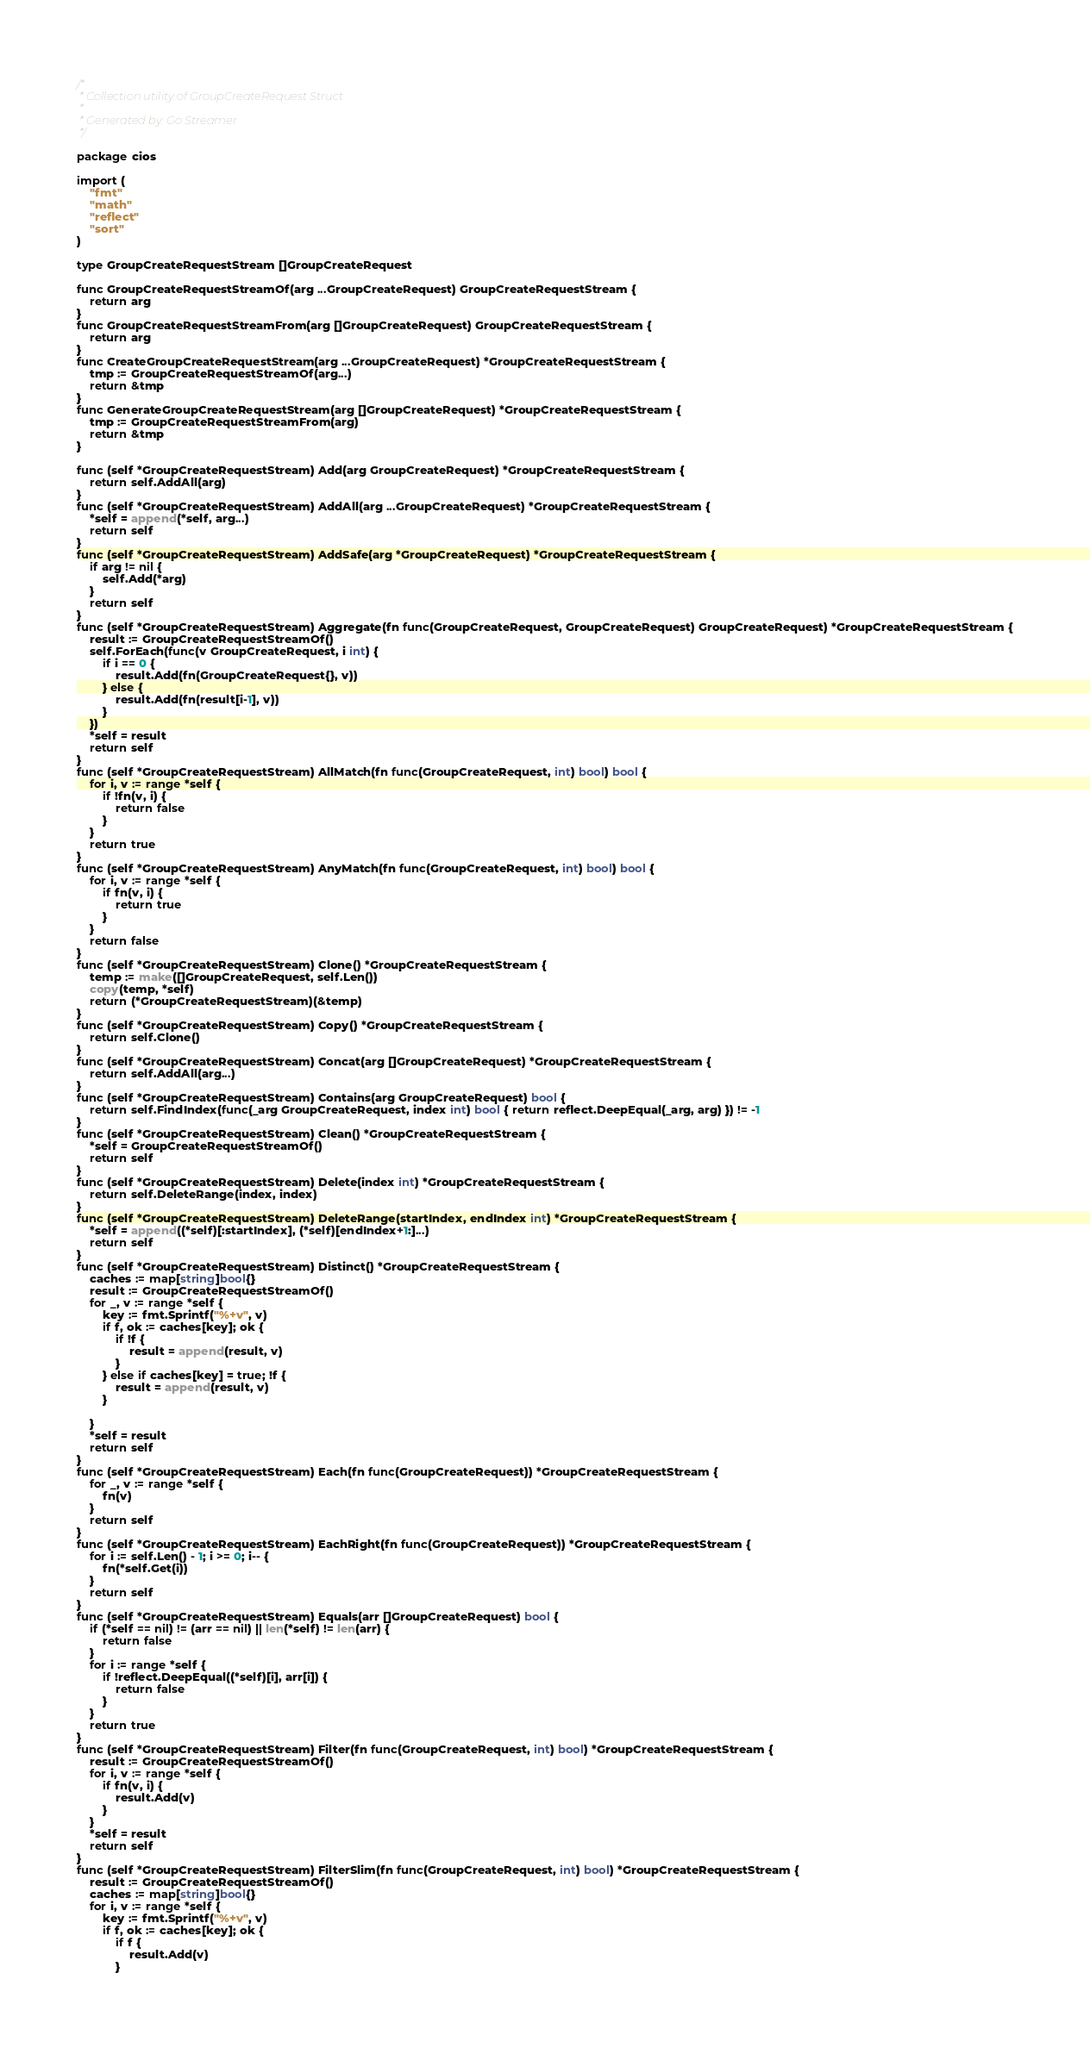Convert code to text. <code><loc_0><loc_0><loc_500><loc_500><_Go_>/*
 * Collection utility of GroupCreateRequest Struct
 *
 * Generated by: Go Streamer
 */

package cios

import (
	"fmt"
	"math"
	"reflect"
	"sort"
)

type GroupCreateRequestStream []GroupCreateRequest

func GroupCreateRequestStreamOf(arg ...GroupCreateRequest) GroupCreateRequestStream {
	return arg
}
func GroupCreateRequestStreamFrom(arg []GroupCreateRequest) GroupCreateRequestStream {
	return arg
}
func CreateGroupCreateRequestStream(arg ...GroupCreateRequest) *GroupCreateRequestStream {
	tmp := GroupCreateRequestStreamOf(arg...)
	return &tmp
}
func GenerateGroupCreateRequestStream(arg []GroupCreateRequest) *GroupCreateRequestStream {
	tmp := GroupCreateRequestStreamFrom(arg)
	return &tmp
}

func (self *GroupCreateRequestStream) Add(arg GroupCreateRequest) *GroupCreateRequestStream {
	return self.AddAll(arg)
}
func (self *GroupCreateRequestStream) AddAll(arg ...GroupCreateRequest) *GroupCreateRequestStream {
	*self = append(*self, arg...)
	return self
}
func (self *GroupCreateRequestStream) AddSafe(arg *GroupCreateRequest) *GroupCreateRequestStream {
	if arg != nil {
		self.Add(*arg)
	}
	return self
}
func (self *GroupCreateRequestStream) Aggregate(fn func(GroupCreateRequest, GroupCreateRequest) GroupCreateRequest) *GroupCreateRequestStream {
	result := GroupCreateRequestStreamOf()
	self.ForEach(func(v GroupCreateRequest, i int) {
		if i == 0 {
			result.Add(fn(GroupCreateRequest{}, v))
		} else {
			result.Add(fn(result[i-1], v))
		}
	})
	*self = result
	return self
}
func (self *GroupCreateRequestStream) AllMatch(fn func(GroupCreateRequest, int) bool) bool {
	for i, v := range *self {
		if !fn(v, i) {
			return false
		}
	}
	return true
}
func (self *GroupCreateRequestStream) AnyMatch(fn func(GroupCreateRequest, int) bool) bool {
	for i, v := range *self {
		if fn(v, i) {
			return true
		}
	}
	return false
}
func (self *GroupCreateRequestStream) Clone() *GroupCreateRequestStream {
	temp := make([]GroupCreateRequest, self.Len())
	copy(temp, *self)
	return (*GroupCreateRequestStream)(&temp)
}
func (self *GroupCreateRequestStream) Copy() *GroupCreateRequestStream {
	return self.Clone()
}
func (self *GroupCreateRequestStream) Concat(arg []GroupCreateRequest) *GroupCreateRequestStream {
	return self.AddAll(arg...)
}
func (self *GroupCreateRequestStream) Contains(arg GroupCreateRequest) bool {
	return self.FindIndex(func(_arg GroupCreateRequest, index int) bool { return reflect.DeepEqual(_arg, arg) }) != -1
}
func (self *GroupCreateRequestStream) Clean() *GroupCreateRequestStream {
	*self = GroupCreateRequestStreamOf()
	return self
}
func (self *GroupCreateRequestStream) Delete(index int) *GroupCreateRequestStream {
	return self.DeleteRange(index, index)
}
func (self *GroupCreateRequestStream) DeleteRange(startIndex, endIndex int) *GroupCreateRequestStream {
	*self = append((*self)[:startIndex], (*self)[endIndex+1:]...)
	return self
}
func (self *GroupCreateRequestStream) Distinct() *GroupCreateRequestStream {
	caches := map[string]bool{}
	result := GroupCreateRequestStreamOf()
	for _, v := range *self {
		key := fmt.Sprintf("%+v", v)
		if f, ok := caches[key]; ok {
			if !f {
				result = append(result, v)
			}
		} else if caches[key] = true; !f {
			result = append(result, v)
		}

	}
	*self = result
	return self
}
func (self *GroupCreateRequestStream) Each(fn func(GroupCreateRequest)) *GroupCreateRequestStream {
	for _, v := range *self {
		fn(v)
	}
	return self
}
func (self *GroupCreateRequestStream) EachRight(fn func(GroupCreateRequest)) *GroupCreateRequestStream {
	for i := self.Len() - 1; i >= 0; i-- {
		fn(*self.Get(i))
	}
	return self
}
func (self *GroupCreateRequestStream) Equals(arr []GroupCreateRequest) bool {
	if (*self == nil) != (arr == nil) || len(*self) != len(arr) {
		return false
	}
	for i := range *self {
		if !reflect.DeepEqual((*self)[i], arr[i]) {
			return false
		}
	}
	return true
}
func (self *GroupCreateRequestStream) Filter(fn func(GroupCreateRequest, int) bool) *GroupCreateRequestStream {
	result := GroupCreateRequestStreamOf()
	for i, v := range *self {
		if fn(v, i) {
			result.Add(v)
		}
	}
	*self = result
	return self
}
func (self *GroupCreateRequestStream) FilterSlim(fn func(GroupCreateRequest, int) bool) *GroupCreateRequestStream {
	result := GroupCreateRequestStreamOf()
	caches := map[string]bool{}
	for i, v := range *self {
		key := fmt.Sprintf("%+v", v)
		if f, ok := caches[key]; ok {
			if f {
				result.Add(v)
			}</code> 